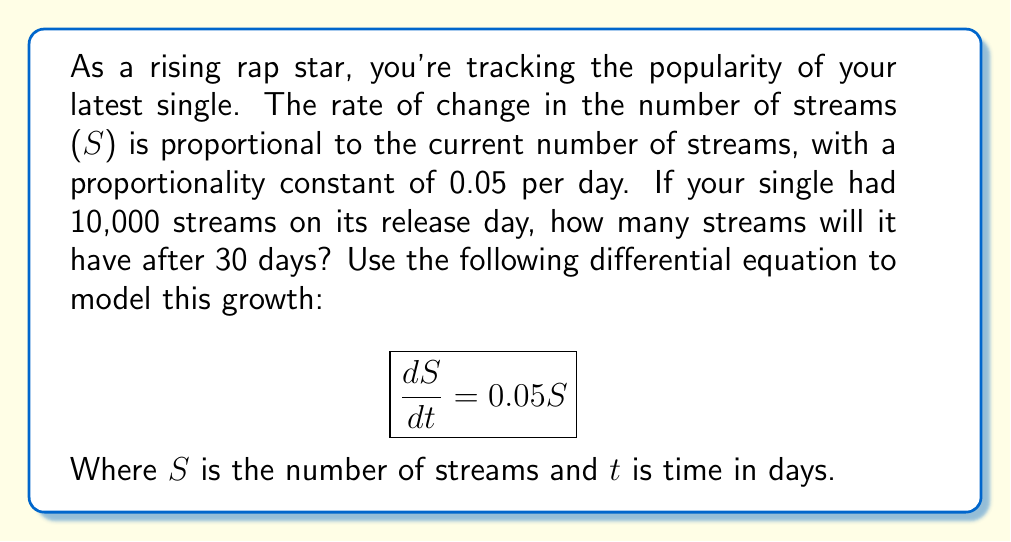Give your solution to this math problem. Let's solve this step-by-step:

1) We have a first-order linear differential equation:
   $$\frac{dS}{dt} = 0.05S$$

2) This is a separable equation. Let's separate the variables:
   $$\frac{dS}{S} = 0.05dt$$

3) Integrate both sides:
   $$\int \frac{dS}{S} = \int 0.05dt$$

4) This gives us:
   $$\ln|S| = 0.05t + C$$

5) Exponentiate both sides:
   $$S = e^{0.05t + C} = e^C \cdot e^{0.05t}$$

6) Let $A = e^C$, so our general solution is:
   $$S = Ae^{0.05t}$$

7) Use the initial condition: when $t=0$, $S=10,000$
   $$10,000 = Ae^{0.05(0)} = A$$

8) So our particular solution is:
   $$S = 10,000e^{0.05t}$$

9) To find the number of streams after 30 days, substitute $t=30$:
   $$S = 10,000e^{0.05(30)} = 10,000e^{1.5} \approx 44,817$$
Answer: 44,817 streams 